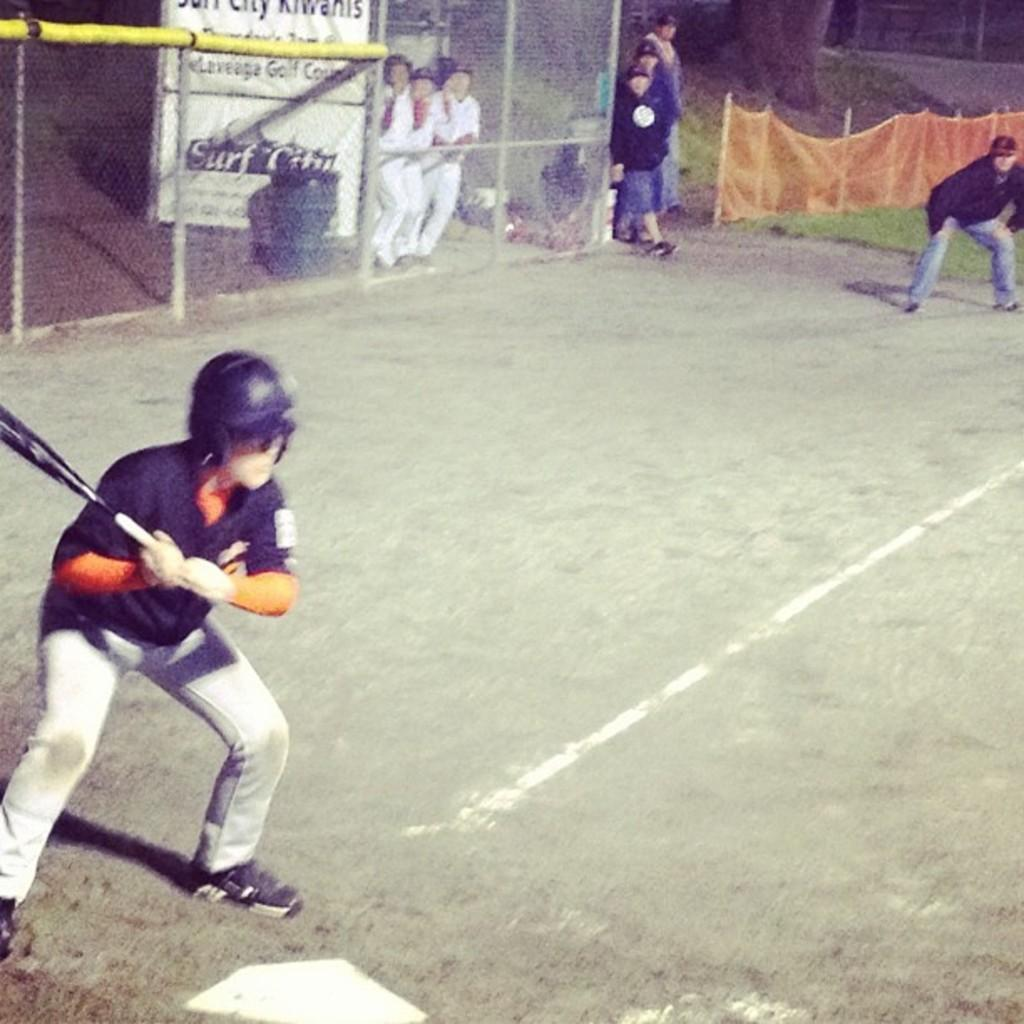<image>
Write a terse but informative summary of the picture. The sign for Surf City is just behind the trash can at this baseball park. 